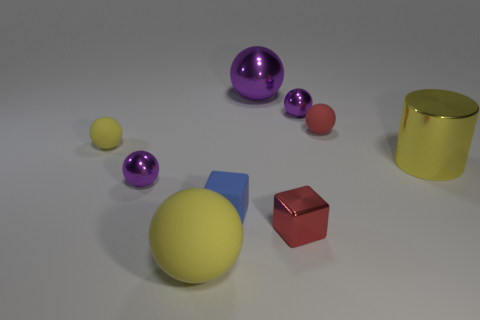There is a rubber sphere that is on the right side of the big yellow matte ball; is there a yellow matte object that is on the right side of it?
Make the answer very short. No. Is the color of the metal sphere that is in front of the big yellow cylinder the same as the rubber object that is to the right of the tiny blue thing?
Ensure brevity in your answer.  No. The large cylinder has what color?
Offer a very short reply. Yellow. Are there any other things that have the same color as the metallic cube?
Provide a succinct answer. Yes. What is the color of the metallic object that is both left of the metal cylinder and right of the red block?
Provide a succinct answer. Purple. Do the metal cylinder that is on the right side of the red metallic object and the large metal sphere have the same size?
Your response must be concise. Yes. Is the number of big yellow rubber spheres to the right of the metallic block greater than the number of small purple shiny spheres?
Provide a succinct answer. No. Do the big yellow metallic thing and the tiny blue object have the same shape?
Give a very brief answer. No. What is the size of the metallic cube?
Offer a terse response. Small. Is the number of tiny red matte things that are to the left of the yellow metal cylinder greater than the number of tiny shiny spheres in front of the small red ball?
Offer a very short reply. No. 